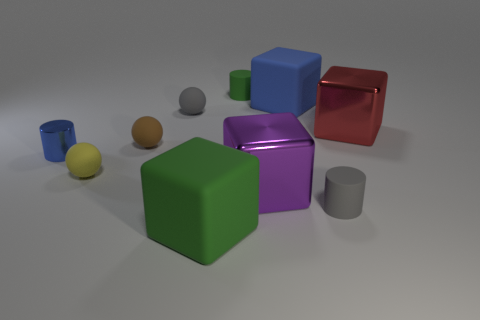How many objects are both on the right side of the big blue matte block and behind the tiny yellow thing?
Ensure brevity in your answer.  1. What size is the blue object left of the tiny rubber cylinder that is on the left side of the small gray rubber cylinder?
Give a very brief answer. Small. Are there fewer large blue rubber things on the right side of the large red metallic block than small blue cylinders right of the large green block?
Your answer should be compact. No. There is a rubber cylinder that is in front of the tiny brown rubber object; is its color the same as the matte cube that is behind the large green matte thing?
Give a very brief answer. No. There is a thing that is both behind the gray cylinder and in front of the yellow object; what is its material?
Offer a terse response. Metal. Is there a large metallic thing?
Your answer should be compact. Yes. What is the shape of the other large thing that is the same material as the big green thing?
Your answer should be compact. Cube. There is a large red shiny thing; is its shape the same as the tiny gray object that is in front of the small brown matte object?
Offer a very short reply. No. What is the material of the tiny yellow thing that is left of the brown ball to the right of the small metallic cylinder?
Ensure brevity in your answer.  Rubber. What number of other things are there of the same shape as the red metallic thing?
Make the answer very short. 3. 